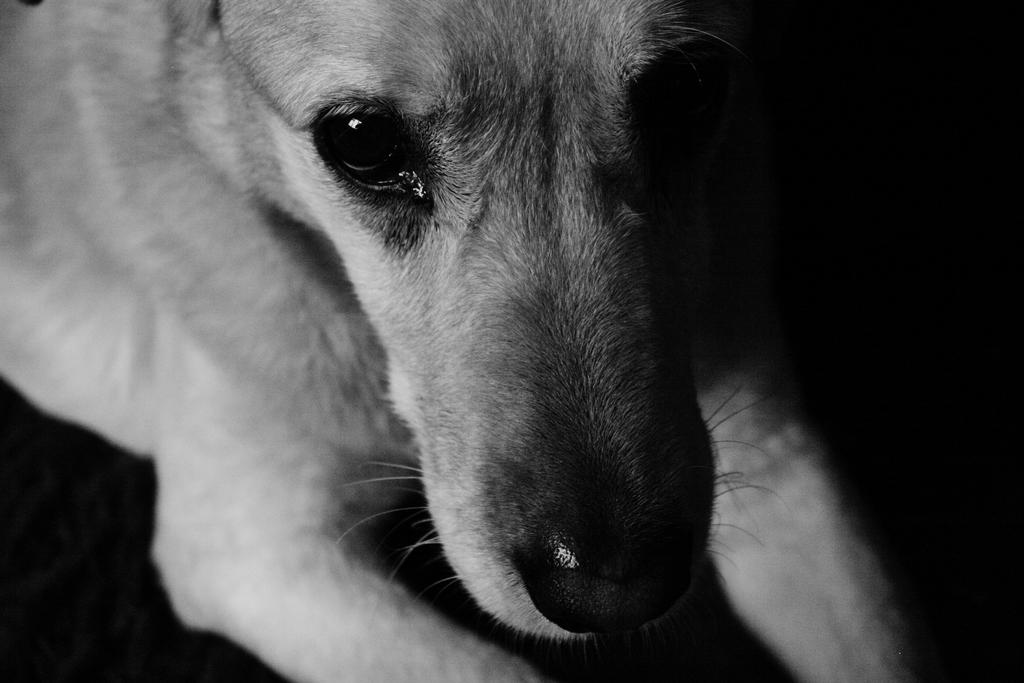What type of animal is present in the image? There is a dog in the image. What invention is being described in the caption below the image? There is no caption present in the image, and therefore no invention can be described. 